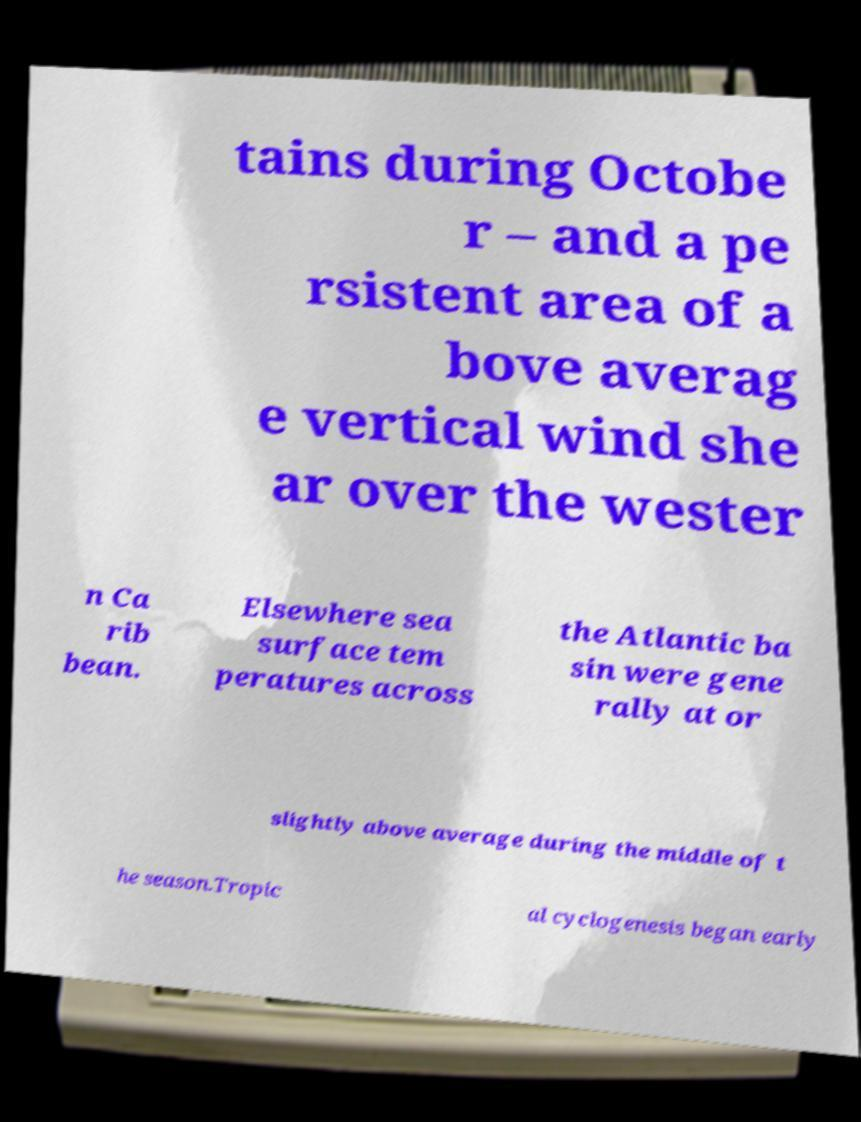Can you read and provide the text displayed in the image?This photo seems to have some interesting text. Can you extract and type it out for me? tains during Octobe r – and a pe rsistent area of a bove averag e vertical wind she ar over the wester n Ca rib bean. Elsewhere sea surface tem peratures across the Atlantic ba sin were gene rally at or slightly above average during the middle of t he season.Tropic al cyclogenesis began early 